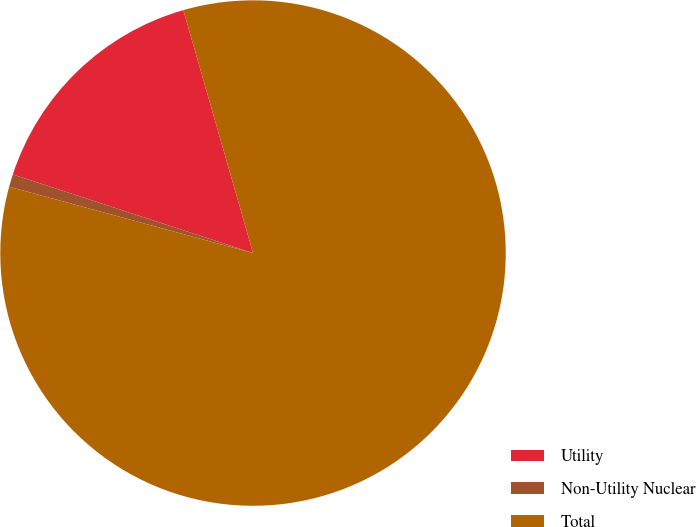Convert chart to OTSL. <chart><loc_0><loc_0><loc_500><loc_500><pie_chart><fcel>Utility<fcel>Non-Utility Nuclear<fcel>Total<nl><fcel>15.52%<fcel>0.81%<fcel>83.68%<nl></chart> 